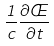<formula> <loc_0><loc_0><loc_500><loc_500>\frac { 1 } { c } \frac { \partial \phi } { \partial t }</formula> 